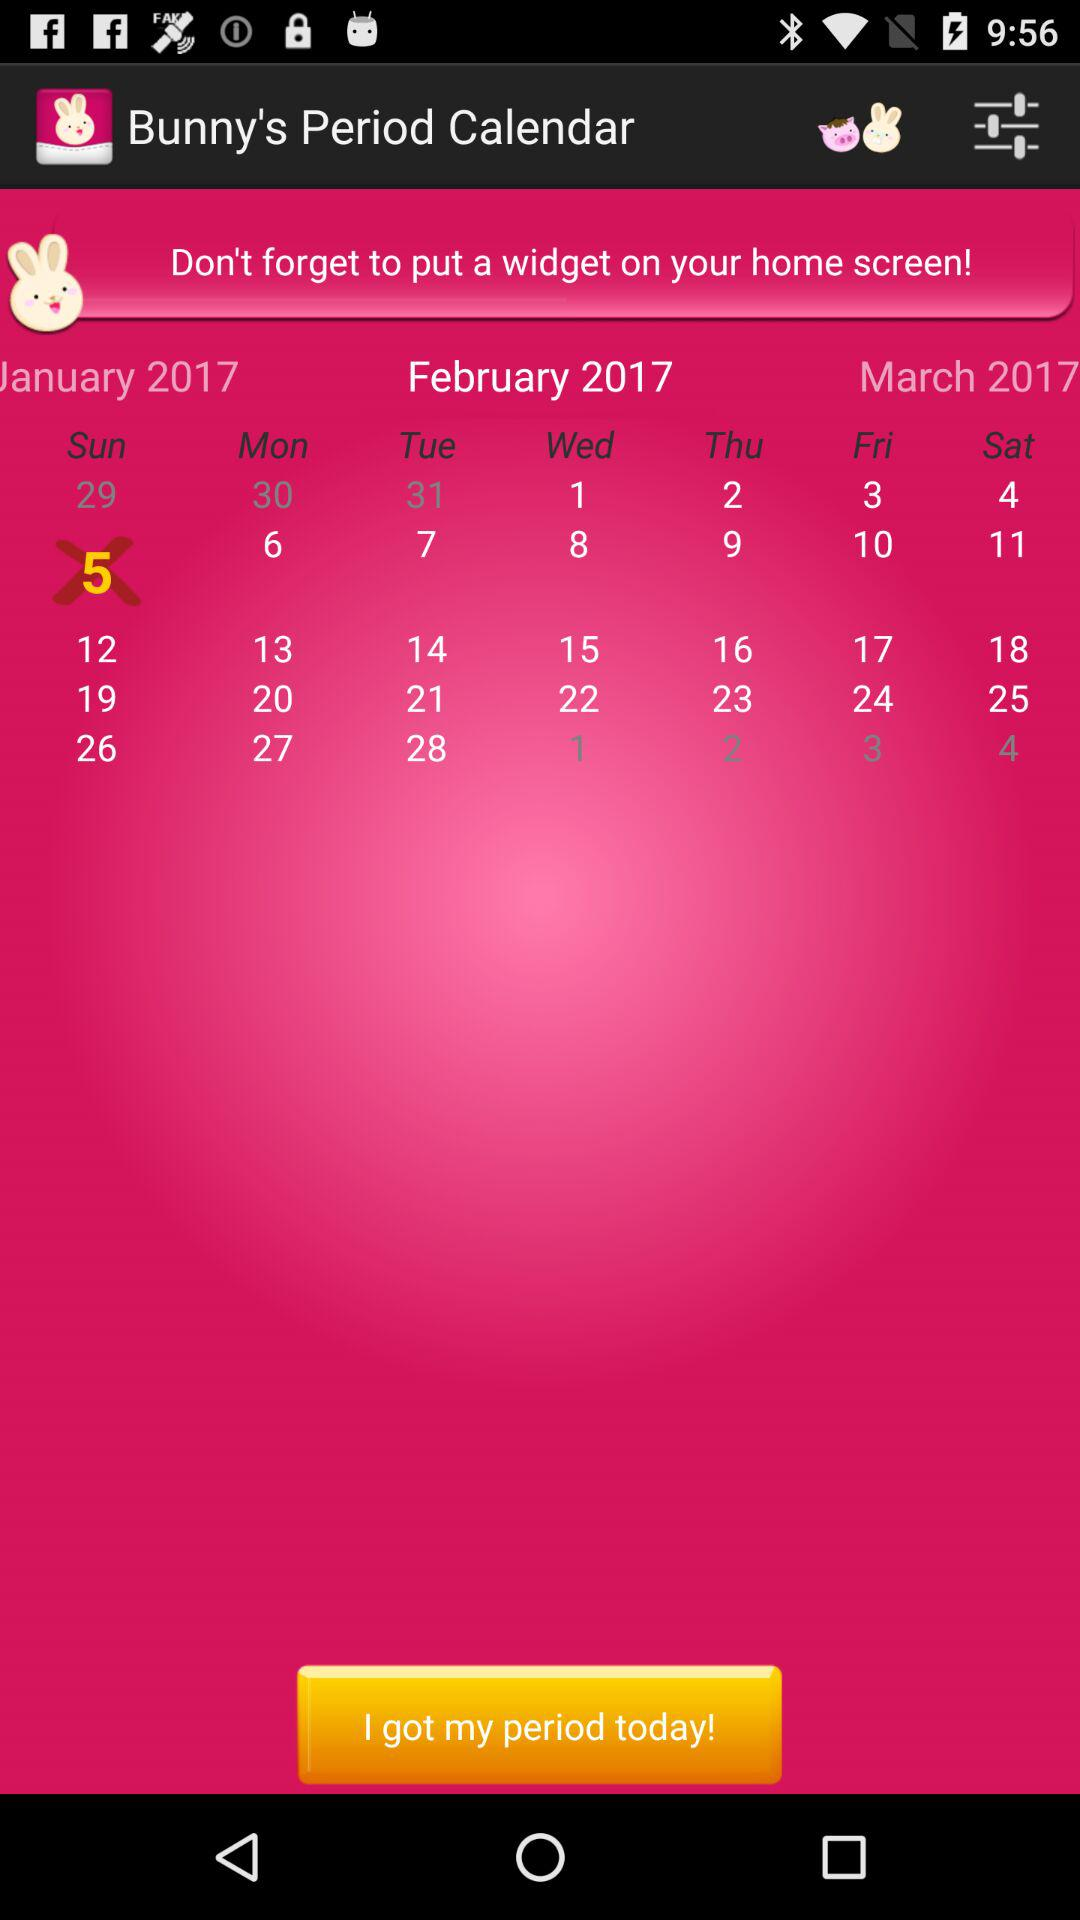Which month's calendar is shown on the screen? On the screen, February's calendar is shown. 